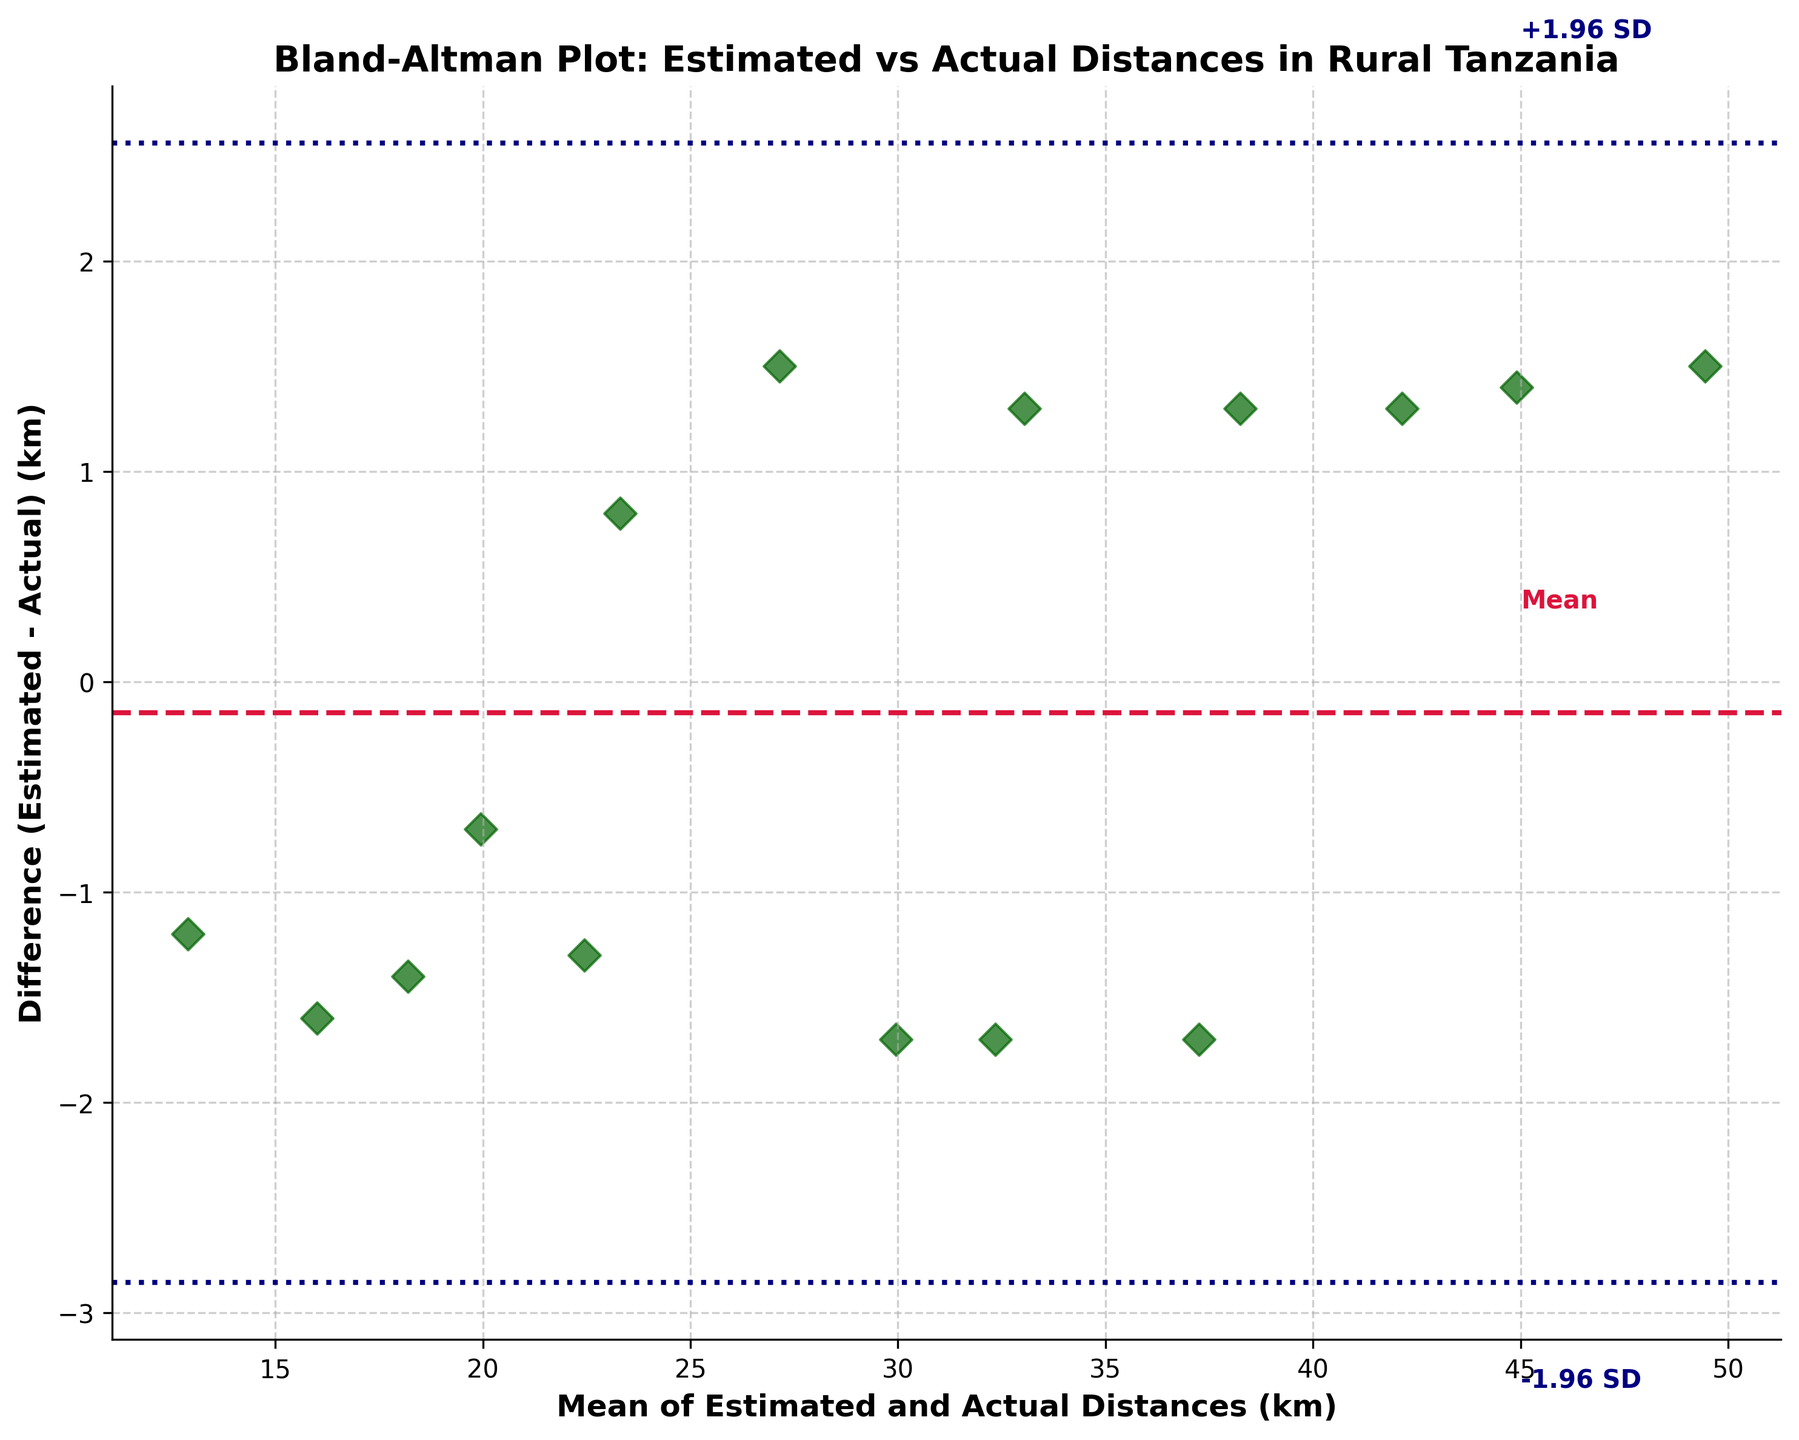How many data points are in the figure? By looking at the scatter plot, each diamond represents a data point. Simply count the total number of diamond markers in the plot.
Answer: 15 What is the title of the figure? The title is usually located at the top of the plot and gives an overview of what the figure represents. It is written in a bold font.
Answer: Bland-Altman Plot: Estimated vs Actual Distances in Rural Tanzania What do the dashed horizontal lines represent? The dashed horizontal lines typically indicate mean and ±1.96 standard deviations from the mean. It helps assess whether the differences between measurements are within acceptable limits.
Answer: Mean and ±1.96 SD What is the range of the mean of estimated and actual distances shown on the x-axis? Examine the x-axis for the smallest and largest values displayed. The x-axis ranges from the smallest to the largest mean value of estimated and actual distances.
Answer: 13.3 to 49.45 km Which color represents the mean line? The mean line is a distinct horizontal line connecting data points in the plot, usually differently styled from other lines. Check the legend in the figure if present.
Answer: Crimson What is the difference between the maximum and minimum difference (estimated - actual)? Identify the highest and lowest values on the y-axis (difference) by observing the scatter plot points' positions and compare these values.
Answer: 2.3 km (from +1.5 to -0.8) Are there any points outside the ±1.96 SD lines? Observe if any diamond markers (data points) lie beyond the dashed lines representing ±1.96 standard deviations from the mean line.
Answer: No What is the mean difference between estimated and actual distances? Locate the middle crimson dashed line which indicates the mean difference. Check the value where this line intersects the y-axis.
Answer: Approx. -0.3 km Which data point has the highest difference (estimated - actual)? Look for the furthest data point above or below the mean line and note the corresponding value. This data point will have the highest positive or negative difference.
Answer: Estimated distance 50.2 km, Actual distance 48.7 km What is the average of the actual distances? Sum all actual distances and divide by the number of data points to obtain the average. This requires adding up all the actual distances from the data and dividing by 15.
Answer: Approx. 27.7 km 